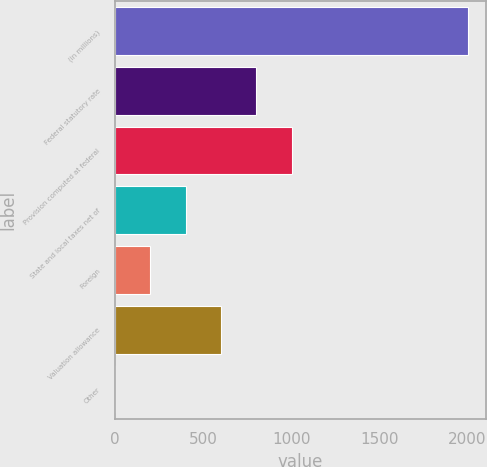<chart> <loc_0><loc_0><loc_500><loc_500><bar_chart><fcel>(in millions)<fcel>Federal statutory rate<fcel>Provision computed at federal<fcel>State and local taxes net of<fcel>Foreign<fcel>Valuation allowance<fcel>Other<nl><fcel>2004<fcel>802.14<fcel>1002.45<fcel>401.52<fcel>201.21<fcel>601.83<fcel>0.9<nl></chart> 